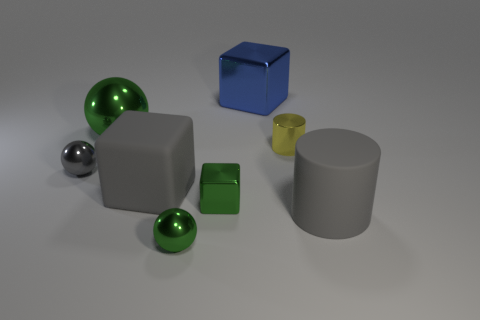Subtract all metal cubes. How many cubes are left? 1 Add 1 tiny yellow cylinders. How many objects exist? 9 Subtract all spheres. How many objects are left? 5 Add 5 purple blocks. How many purple blocks exist? 5 Subtract 0 purple blocks. How many objects are left? 8 Subtract all small gray spheres. Subtract all small spheres. How many objects are left? 5 Add 5 big metallic balls. How many big metallic balls are left? 6 